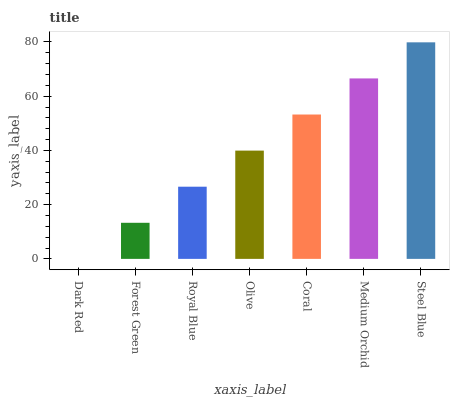Is Dark Red the minimum?
Answer yes or no. Yes. Is Steel Blue the maximum?
Answer yes or no. Yes. Is Forest Green the minimum?
Answer yes or no. No. Is Forest Green the maximum?
Answer yes or no. No. Is Forest Green greater than Dark Red?
Answer yes or no. Yes. Is Dark Red less than Forest Green?
Answer yes or no. Yes. Is Dark Red greater than Forest Green?
Answer yes or no. No. Is Forest Green less than Dark Red?
Answer yes or no. No. Is Olive the high median?
Answer yes or no. Yes. Is Olive the low median?
Answer yes or no. Yes. Is Forest Green the high median?
Answer yes or no. No. Is Coral the low median?
Answer yes or no. No. 